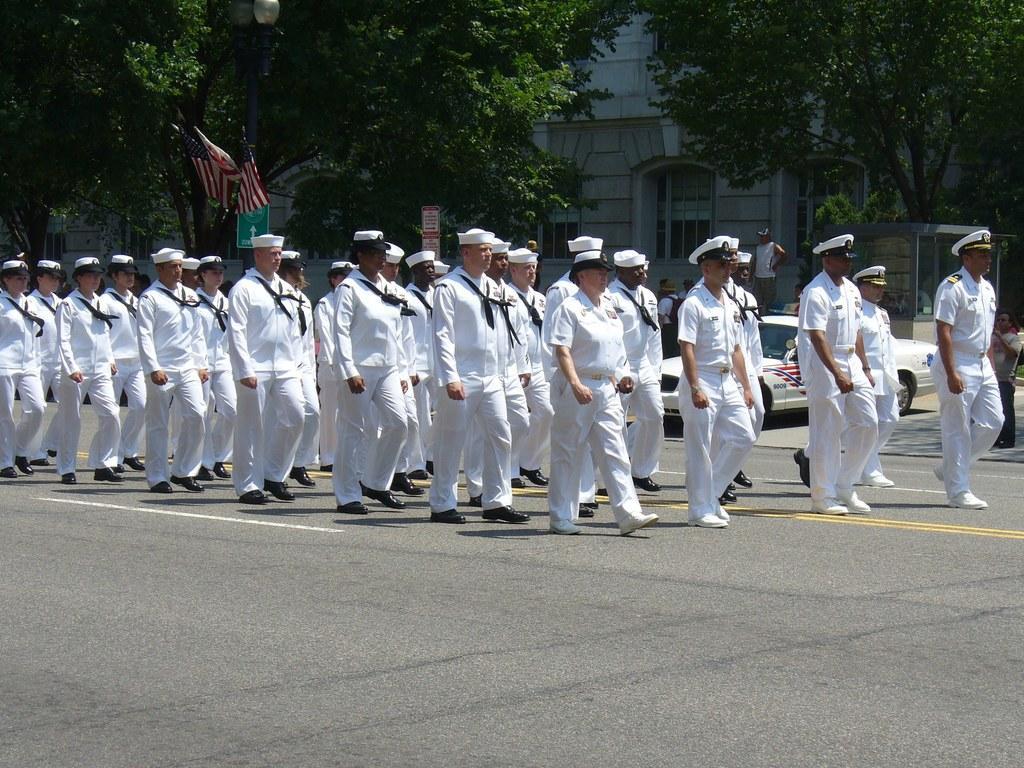Describe this image in one or two sentences. In this image we can see a group of people wearing caps are standing on the ground. On the right side of the image we can see a car parked on the ground. On the left side of the image we can see flags on the tree. In the background, we can see a building with windows, a tree and sign boards with some text. 